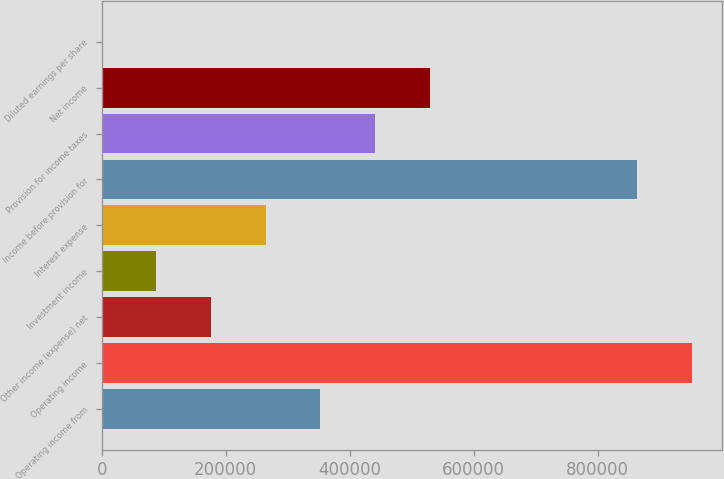Convert chart to OTSL. <chart><loc_0><loc_0><loc_500><loc_500><bar_chart><fcel>Operating income from<fcel>Operating income<fcel>Other income (expense) net<fcel>Investment income<fcel>Interest expense<fcel>Income before provision for<fcel>Provision for income taxes<fcel>Net income<fcel>Diluted earnings per share<nl><fcel>352834<fcel>952047<fcel>176419<fcel>88210.8<fcel>264626<fcel>863839<fcel>441042<fcel>529250<fcel>3.02<nl></chart> 